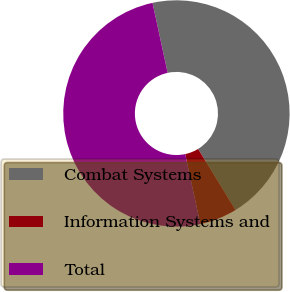Convert chart to OTSL. <chart><loc_0><loc_0><loc_500><loc_500><pie_chart><fcel>Combat Systems<fcel>Information Systems and<fcel>Total<nl><fcel>44.64%<fcel>5.36%<fcel>50.0%<nl></chart> 